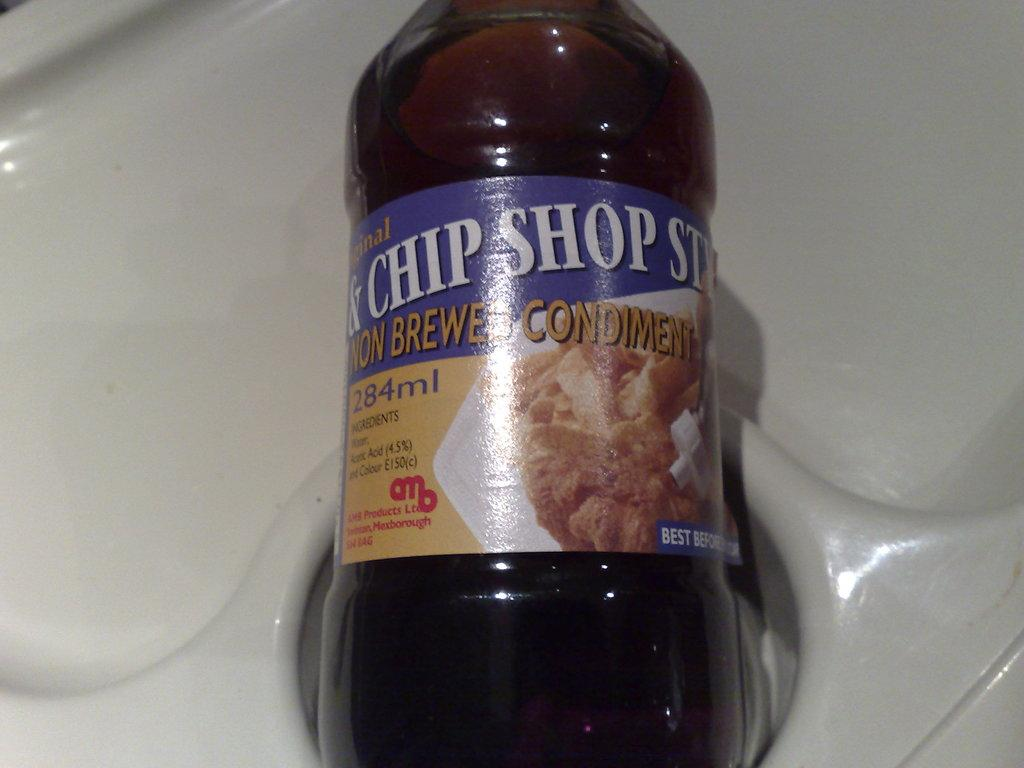Provide a one-sentence caption for the provided image. The sauce has 284ml of flavor that will go well with cooking. 